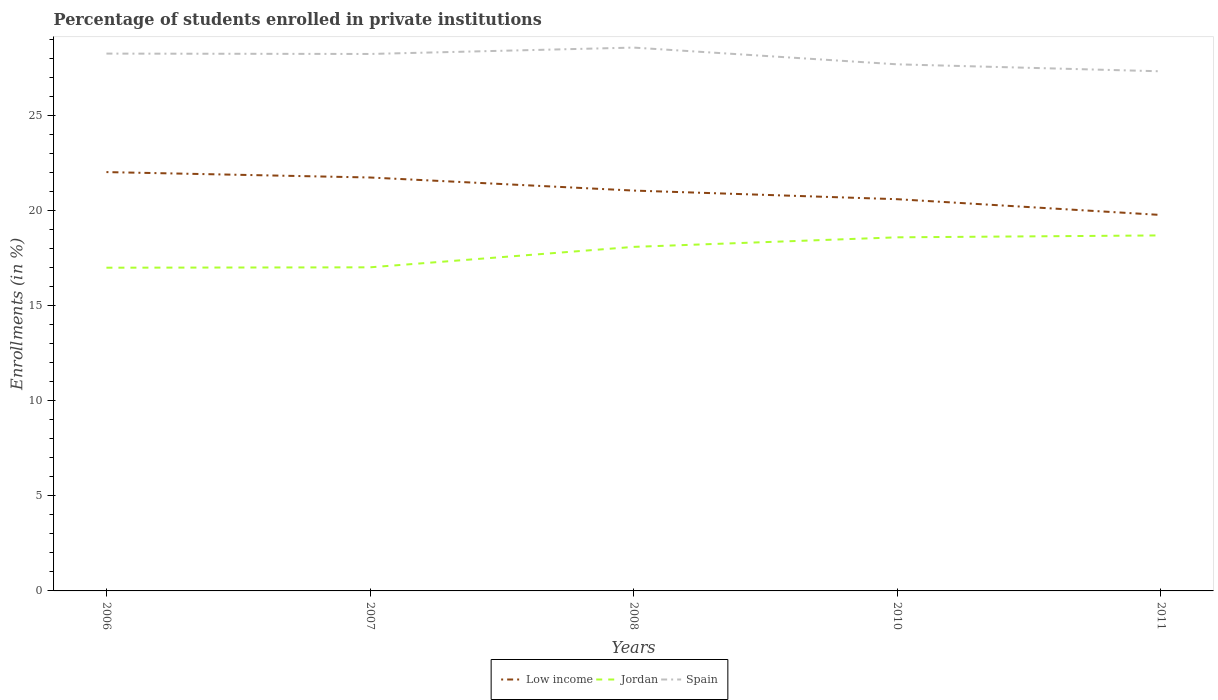How many different coloured lines are there?
Provide a succinct answer. 3. Across all years, what is the maximum percentage of trained teachers in Spain?
Your answer should be compact. 27.31. In which year was the percentage of trained teachers in Jordan maximum?
Offer a terse response. 2006. What is the total percentage of trained teachers in Jordan in the graph?
Make the answer very short. -0.1. What is the difference between the highest and the second highest percentage of trained teachers in Low income?
Keep it short and to the point. 2.25. What is the difference between the highest and the lowest percentage of trained teachers in Jordan?
Your answer should be very brief. 3. How many years are there in the graph?
Make the answer very short. 5. What is the difference between two consecutive major ticks on the Y-axis?
Make the answer very short. 5. Does the graph contain any zero values?
Your response must be concise. No. Does the graph contain grids?
Your response must be concise. No. How are the legend labels stacked?
Make the answer very short. Horizontal. What is the title of the graph?
Your answer should be compact. Percentage of students enrolled in private institutions. What is the label or title of the Y-axis?
Ensure brevity in your answer.  Enrollments (in %). What is the Enrollments (in %) of Low income in 2006?
Offer a very short reply. 22.01. What is the Enrollments (in %) of Jordan in 2006?
Keep it short and to the point. 16.99. What is the Enrollments (in %) in Spain in 2006?
Your response must be concise. 28.24. What is the Enrollments (in %) of Low income in 2007?
Offer a terse response. 21.73. What is the Enrollments (in %) in Jordan in 2007?
Ensure brevity in your answer.  17.01. What is the Enrollments (in %) in Spain in 2007?
Your answer should be compact. 28.22. What is the Enrollments (in %) of Low income in 2008?
Keep it short and to the point. 21.04. What is the Enrollments (in %) in Jordan in 2008?
Keep it short and to the point. 18.08. What is the Enrollments (in %) of Spain in 2008?
Your answer should be compact. 28.56. What is the Enrollments (in %) in Low income in 2010?
Your response must be concise. 20.59. What is the Enrollments (in %) of Jordan in 2010?
Make the answer very short. 18.58. What is the Enrollments (in %) of Spain in 2010?
Provide a succinct answer. 27.68. What is the Enrollments (in %) in Low income in 2011?
Your answer should be very brief. 19.76. What is the Enrollments (in %) of Jordan in 2011?
Provide a succinct answer. 18.68. What is the Enrollments (in %) in Spain in 2011?
Offer a very short reply. 27.31. Across all years, what is the maximum Enrollments (in %) in Low income?
Provide a succinct answer. 22.01. Across all years, what is the maximum Enrollments (in %) of Jordan?
Your answer should be very brief. 18.68. Across all years, what is the maximum Enrollments (in %) in Spain?
Your answer should be compact. 28.56. Across all years, what is the minimum Enrollments (in %) of Low income?
Keep it short and to the point. 19.76. Across all years, what is the minimum Enrollments (in %) in Jordan?
Your answer should be compact. 16.99. Across all years, what is the minimum Enrollments (in %) in Spain?
Provide a short and direct response. 27.31. What is the total Enrollments (in %) in Low income in the graph?
Provide a succinct answer. 105.13. What is the total Enrollments (in %) in Jordan in the graph?
Your answer should be very brief. 89.34. What is the total Enrollments (in %) in Spain in the graph?
Provide a succinct answer. 140. What is the difference between the Enrollments (in %) of Low income in 2006 and that in 2007?
Offer a terse response. 0.28. What is the difference between the Enrollments (in %) in Jordan in 2006 and that in 2007?
Your answer should be very brief. -0.02. What is the difference between the Enrollments (in %) in Spain in 2006 and that in 2007?
Ensure brevity in your answer.  0.02. What is the difference between the Enrollments (in %) in Low income in 2006 and that in 2008?
Offer a terse response. 0.97. What is the difference between the Enrollments (in %) in Jordan in 2006 and that in 2008?
Provide a short and direct response. -1.09. What is the difference between the Enrollments (in %) in Spain in 2006 and that in 2008?
Provide a succinct answer. -0.32. What is the difference between the Enrollments (in %) of Low income in 2006 and that in 2010?
Provide a succinct answer. 1.43. What is the difference between the Enrollments (in %) of Jordan in 2006 and that in 2010?
Your response must be concise. -1.6. What is the difference between the Enrollments (in %) of Spain in 2006 and that in 2010?
Offer a very short reply. 0.56. What is the difference between the Enrollments (in %) in Low income in 2006 and that in 2011?
Offer a terse response. 2.25. What is the difference between the Enrollments (in %) in Jordan in 2006 and that in 2011?
Your answer should be compact. -1.7. What is the difference between the Enrollments (in %) in Spain in 2006 and that in 2011?
Your response must be concise. 0.93. What is the difference between the Enrollments (in %) in Low income in 2007 and that in 2008?
Your answer should be compact. 0.69. What is the difference between the Enrollments (in %) of Jordan in 2007 and that in 2008?
Your answer should be compact. -1.07. What is the difference between the Enrollments (in %) in Spain in 2007 and that in 2008?
Keep it short and to the point. -0.34. What is the difference between the Enrollments (in %) in Low income in 2007 and that in 2010?
Ensure brevity in your answer.  1.14. What is the difference between the Enrollments (in %) in Jordan in 2007 and that in 2010?
Offer a terse response. -1.58. What is the difference between the Enrollments (in %) of Spain in 2007 and that in 2010?
Ensure brevity in your answer.  0.54. What is the difference between the Enrollments (in %) in Low income in 2007 and that in 2011?
Offer a very short reply. 1.97. What is the difference between the Enrollments (in %) of Jordan in 2007 and that in 2011?
Keep it short and to the point. -1.68. What is the difference between the Enrollments (in %) in Spain in 2007 and that in 2011?
Ensure brevity in your answer.  0.91. What is the difference between the Enrollments (in %) of Low income in 2008 and that in 2010?
Offer a terse response. 0.45. What is the difference between the Enrollments (in %) of Jordan in 2008 and that in 2010?
Make the answer very short. -0.5. What is the difference between the Enrollments (in %) of Low income in 2008 and that in 2011?
Your answer should be compact. 1.28. What is the difference between the Enrollments (in %) in Jordan in 2008 and that in 2011?
Your response must be concise. -0.6. What is the difference between the Enrollments (in %) of Spain in 2008 and that in 2011?
Keep it short and to the point. 1.25. What is the difference between the Enrollments (in %) of Low income in 2010 and that in 2011?
Keep it short and to the point. 0.83. What is the difference between the Enrollments (in %) of Jordan in 2010 and that in 2011?
Your answer should be compact. -0.1. What is the difference between the Enrollments (in %) of Spain in 2010 and that in 2011?
Keep it short and to the point. 0.37. What is the difference between the Enrollments (in %) in Low income in 2006 and the Enrollments (in %) in Jordan in 2007?
Offer a terse response. 5.01. What is the difference between the Enrollments (in %) of Low income in 2006 and the Enrollments (in %) of Spain in 2007?
Ensure brevity in your answer.  -6.21. What is the difference between the Enrollments (in %) of Jordan in 2006 and the Enrollments (in %) of Spain in 2007?
Keep it short and to the point. -11.23. What is the difference between the Enrollments (in %) in Low income in 2006 and the Enrollments (in %) in Jordan in 2008?
Your response must be concise. 3.93. What is the difference between the Enrollments (in %) in Low income in 2006 and the Enrollments (in %) in Spain in 2008?
Keep it short and to the point. -6.54. What is the difference between the Enrollments (in %) of Jordan in 2006 and the Enrollments (in %) of Spain in 2008?
Your response must be concise. -11.57. What is the difference between the Enrollments (in %) of Low income in 2006 and the Enrollments (in %) of Jordan in 2010?
Give a very brief answer. 3.43. What is the difference between the Enrollments (in %) in Low income in 2006 and the Enrollments (in %) in Spain in 2010?
Your response must be concise. -5.66. What is the difference between the Enrollments (in %) of Jordan in 2006 and the Enrollments (in %) of Spain in 2010?
Your response must be concise. -10.69. What is the difference between the Enrollments (in %) of Low income in 2006 and the Enrollments (in %) of Jordan in 2011?
Ensure brevity in your answer.  3.33. What is the difference between the Enrollments (in %) in Low income in 2006 and the Enrollments (in %) in Spain in 2011?
Your answer should be very brief. -5.3. What is the difference between the Enrollments (in %) in Jordan in 2006 and the Enrollments (in %) in Spain in 2011?
Your response must be concise. -10.32. What is the difference between the Enrollments (in %) of Low income in 2007 and the Enrollments (in %) of Jordan in 2008?
Make the answer very short. 3.65. What is the difference between the Enrollments (in %) in Low income in 2007 and the Enrollments (in %) in Spain in 2008?
Offer a terse response. -6.83. What is the difference between the Enrollments (in %) in Jordan in 2007 and the Enrollments (in %) in Spain in 2008?
Provide a succinct answer. -11.55. What is the difference between the Enrollments (in %) in Low income in 2007 and the Enrollments (in %) in Jordan in 2010?
Make the answer very short. 3.14. What is the difference between the Enrollments (in %) of Low income in 2007 and the Enrollments (in %) of Spain in 2010?
Provide a short and direct response. -5.95. What is the difference between the Enrollments (in %) of Jordan in 2007 and the Enrollments (in %) of Spain in 2010?
Make the answer very short. -10.67. What is the difference between the Enrollments (in %) of Low income in 2007 and the Enrollments (in %) of Jordan in 2011?
Your answer should be very brief. 3.04. What is the difference between the Enrollments (in %) in Low income in 2007 and the Enrollments (in %) in Spain in 2011?
Offer a terse response. -5.58. What is the difference between the Enrollments (in %) in Jordan in 2007 and the Enrollments (in %) in Spain in 2011?
Your answer should be very brief. -10.3. What is the difference between the Enrollments (in %) of Low income in 2008 and the Enrollments (in %) of Jordan in 2010?
Give a very brief answer. 2.46. What is the difference between the Enrollments (in %) of Low income in 2008 and the Enrollments (in %) of Spain in 2010?
Your answer should be compact. -6.63. What is the difference between the Enrollments (in %) of Jordan in 2008 and the Enrollments (in %) of Spain in 2010?
Ensure brevity in your answer.  -9.59. What is the difference between the Enrollments (in %) in Low income in 2008 and the Enrollments (in %) in Jordan in 2011?
Ensure brevity in your answer.  2.36. What is the difference between the Enrollments (in %) in Low income in 2008 and the Enrollments (in %) in Spain in 2011?
Give a very brief answer. -6.27. What is the difference between the Enrollments (in %) in Jordan in 2008 and the Enrollments (in %) in Spain in 2011?
Provide a succinct answer. -9.23. What is the difference between the Enrollments (in %) of Low income in 2010 and the Enrollments (in %) of Jordan in 2011?
Ensure brevity in your answer.  1.9. What is the difference between the Enrollments (in %) in Low income in 2010 and the Enrollments (in %) in Spain in 2011?
Keep it short and to the point. -6.72. What is the difference between the Enrollments (in %) in Jordan in 2010 and the Enrollments (in %) in Spain in 2011?
Your response must be concise. -8.73. What is the average Enrollments (in %) in Low income per year?
Your answer should be compact. 21.03. What is the average Enrollments (in %) of Jordan per year?
Provide a succinct answer. 17.87. What is the average Enrollments (in %) in Spain per year?
Your answer should be compact. 28. In the year 2006, what is the difference between the Enrollments (in %) in Low income and Enrollments (in %) in Jordan?
Provide a short and direct response. 5.02. In the year 2006, what is the difference between the Enrollments (in %) of Low income and Enrollments (in %) of Spain?
Keep it short and to the point. -6.23. In the year 2006, what is the difference between the Enrollments (in %) in Jordan and Enrollments (in %) in Spain?
Offer a very short reply. -11.25. In the year 2007, what is the difference between the Enrollments (in %) of Low income and Enrollments (in %) of Jordan?
Give a very brief answer. 4.72. In the year 2007, what is the difference between the Enrollments (in %) of Low income and Enrollments (in %) of Spain?
Provide a succinct answer. -6.49. In the year 2007, what is the difference between the Enrollments (in %) in Jordan and Enrollments (in %) in Spain?
Give a very brief answer. -11.21. In the year 2008, what is the difference between the Enrollments (in %) of Low income and Enrollments (in %) of Jordan?
Ensure brevity in your answer.  2.96. In the year 2008, what is the difference between the Enrollments (in %) of Low income and Enrollments (in %) of Spain?
Ensure brevity in your answer.  -7.51. In the year 2008, what is the difference between the Enrollments (in %) in Jordan and Enrollments (in %) in Spain?
Provide a short and direct response. -10.47. In the year 2010, what is the difference between the Enrollments (in %) of Low income and Enrollments (in %) of Jordan?
Your response must be concise. 2. In the year 2010, what is the difference between the Enrollments (in %) in Low income and Enrollments (in %) in Spain?
Provide a succinct answer. -7.09. In the year 2010, what is the difference between the Enrollments (in %) in Jordan and Enrollments (in %) in Spain?
Keep it short and to the point. -9.09. In the year 2011, what is the difference between the Enrollments (in %) in Low income and Enrollments (in %) in Jordan?
Your answer should be very brief. 1.08. In the year 2011, what is the difference between the Enrollments (in %) of Low income and Enrollments (in %) of Spain?
Offer a terse response. -7.55. In the year 2011, what is the difference between the Enrollments (in %) in Jordan and Enrollments (in %) in Spain?
Keep it short and to the point. -8.63. What is the ratio of the Enrollments (in %) of Low income in 2006 to that in 2007?
Ensure brevity in your answer.  1.01. What is the ratio of the Enrollments (in %) in Jordan in 2006 to that in 2007?
Your response must be concise. 1. What is the ratio of the Enrollments (in %) of Low income in 2006 to that in 2008?
Your answer should be very brief. 1.05. What is the ratio of the Enrollments (in %) in Jordan in 2006 to that in 2008?
Your response must be concise. 0.94. What is the ratio of the Enrollments (in %) of Spain in 2006 to that in 2008?
Your answer should be very brief. 0.99. What is the ratio of the Enrollments (in %) of Low income in 2006 to that in 2010?
Your answer should be compact. 1.07. What is the ratio of the Enrollments (in %) in Jordan in 2006 to that in 2010?
Make the answer very short. 0.91. What is the ratio of the Enrollments (in %) of Spain in 2006 to that in 2010?
Ensure brevity in your answer.  1.02. What is the ratio of the Enrollments (in %) of Low income in 2006 to that in 2011?
Provide a succinct answer. 1.11. What is the ratio of the Enrollments (in %) of Jordan in 2006 to that in 2011?
Your response must be concise. 0.91. What is the ratio of the Enrollments (in %) of Spain in 2006 to that in 2011?
Give a very brief answer. 1.03. What is the ratio of the Enrollments (in %) in Low income in 2007 to that in 2008?
Your answer should be very brief. 1.03. What is the ratio of the Enrollments (in %) in Jordan in 2007 to that in 2008?
Your response must be concise. 0.94. What is the ratio of the Enrollments (in %) in Spain in 2007 to that in 2008?
Ensure brevity in your answer.  0.99. What is the ratio of the Enrollments (in %) in Low income in 2007 to that in 2010?
Your response must be concise. 1.06. What is the ratio of the Enrollments (in %) in Jordan in 2007 to that in 2010?
Keep it short and to the point. 0.92. What is the ratio of the Enrollments (in %) in Spain in 2007 to that in 2010?
Give a very brief answer. 1.02. What is the ratio of the Enrollments (in %) in Low income in 2007 to that in 2011?
Your answer should be compact. 1.1. What is the ratio of the Enrollments (in %) in Jordan in 2007 to that in 2011?
Your answer should be compact. 0.91. What is the ratio of the Enrollments (in %) in Spain in 2007 to that in 2011?
Ensure brevity in your answer.  1.03. What is the ratio of the Enrollments (in %) of Spain in 2008 to that in 2010?
Offer a very short reply. 1.03. What is the ratio of the Enrollments (in %) in Low income in 2008 to that in 2011?
Keep it short and to the point. 1.06. What is the ratio of the Enrollments (in %) of Jordan in 2008 to that in 2011?
Your answer should be compact. 0.97. What is the ratio of the Enrollments (in %) in Spain in 2008 to that in 2011?
Give a very brief answer. 1.05. What is the ratio of the Enrollments (in %) in Low income in 2010 to that in 2011?
Make the answer very short. 1.04. What is the ratio of the Enrollments (in %) of Jordan in 2010 to that in 2011?
Offer a very short reply. 0.99. What is the ratio of the Enrollments (in %) in Spain in 2010 to that in 2011?
Offer a very short reply. 1.01. What is the difference between the highest and the second highest Enrollments (in %) in Low income?
Keep it short and to the point. 0.28. What is the difference between the highest and the second highest Enrollments (in %) in Jordan?
Your answer should be compact. 0.1. What is the difference between the highest and the second highest Enrollments (in %) of Spain?
Your answer should be very brief. 0.32. What is the difference between the highest and the lowest Enrollments (in %) in Low income?
Your answer should be very brief. 2.25. What is the difference between the highest and the lowest Enrollments (in %) in Jordan?
Your response must be concise. 1.7. What is the difference between the highest and the lowest Enrollments (in %) in Spain?
Your response must be concise. 1.25. 